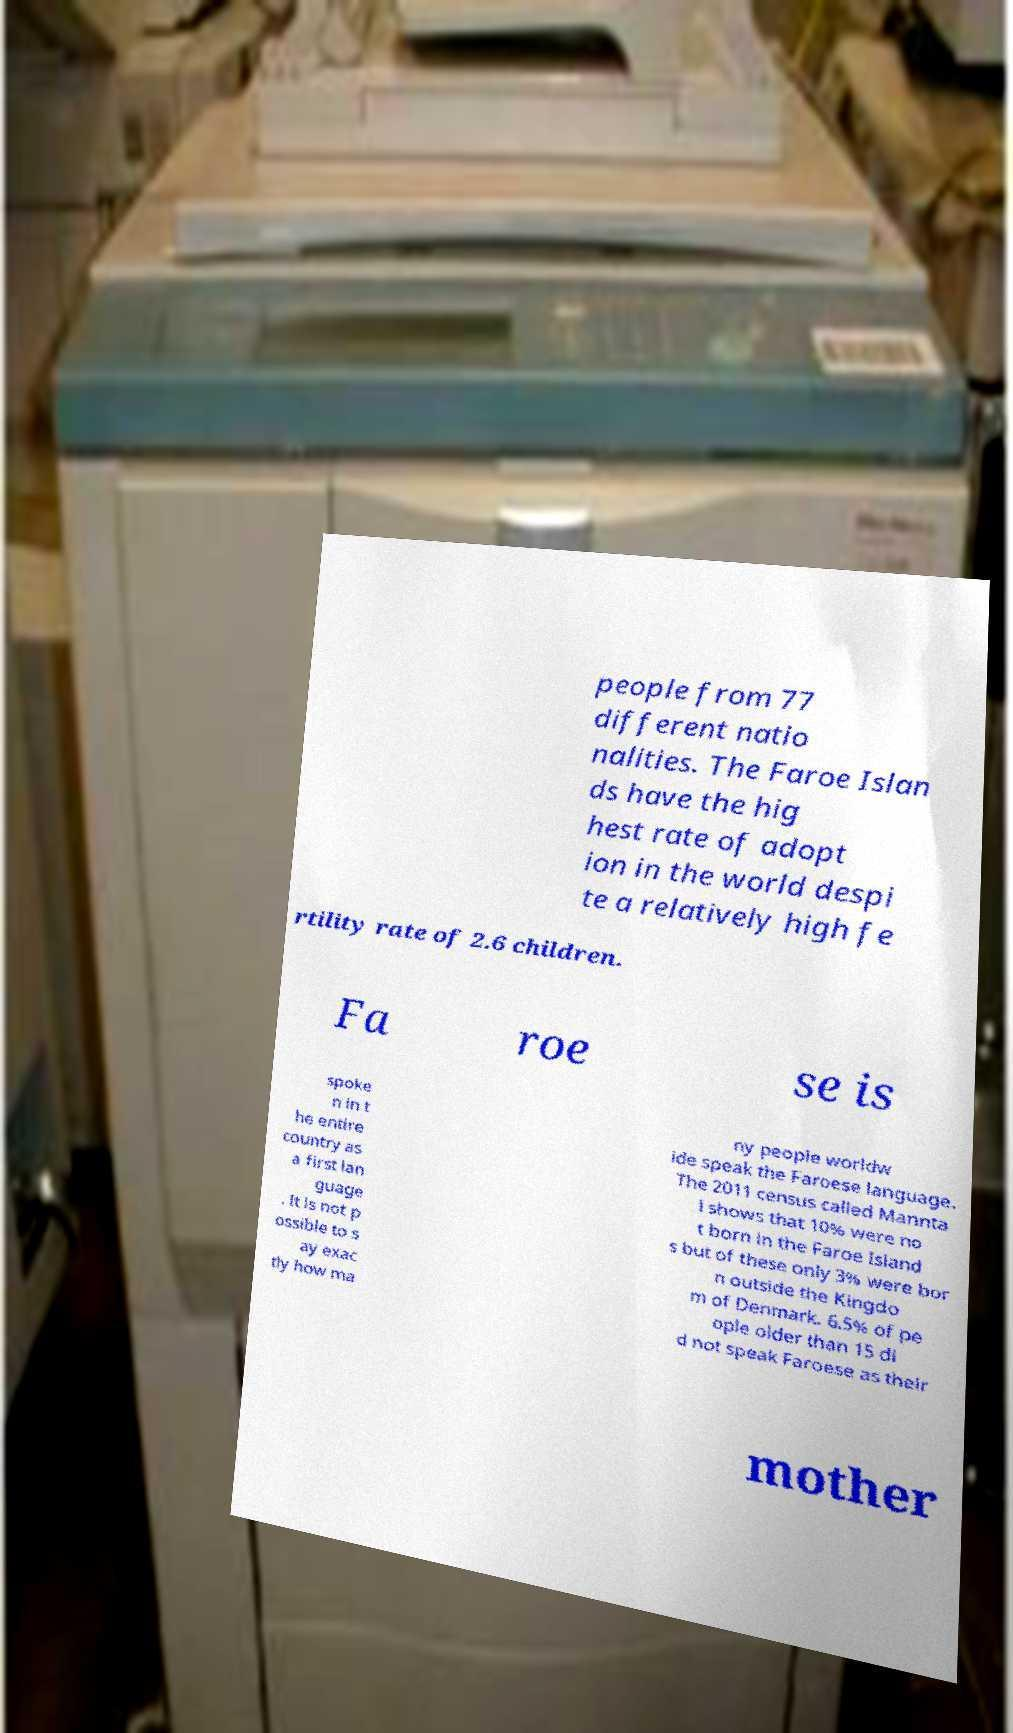Please read and relay the text visible in this image. What does it say? people from 77 different natio nalities. The Faroe Islan ds have the hig hest rate of adopt ion in the world despi te a relatively high fe rtility rate of 2.6 children. Fa roe se is spoke n in t he entire country as a first lan guage . It is not p ossible to s ay exac tly how ma ny people worldw ide speak the Faroese language. The 2011 census called Mannta l shows that 10% were no t born in the Faroe Island s but of these only 3% were bor n outside the Kingdo m of Denmark. 6.5% of pe ople older than 15 di d not speak Faroese as their mother 